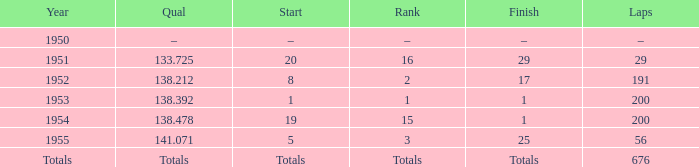What finish qualified at 141.071? 25.0. 